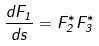Convert formula to latex. <formula><loc_0><loc_0><loc_500><loc_500>\frac { d F _ { 1 } } { d s } = F _ { 2 } ^ { * } F _ { 3 } ^ { * }</formula> 